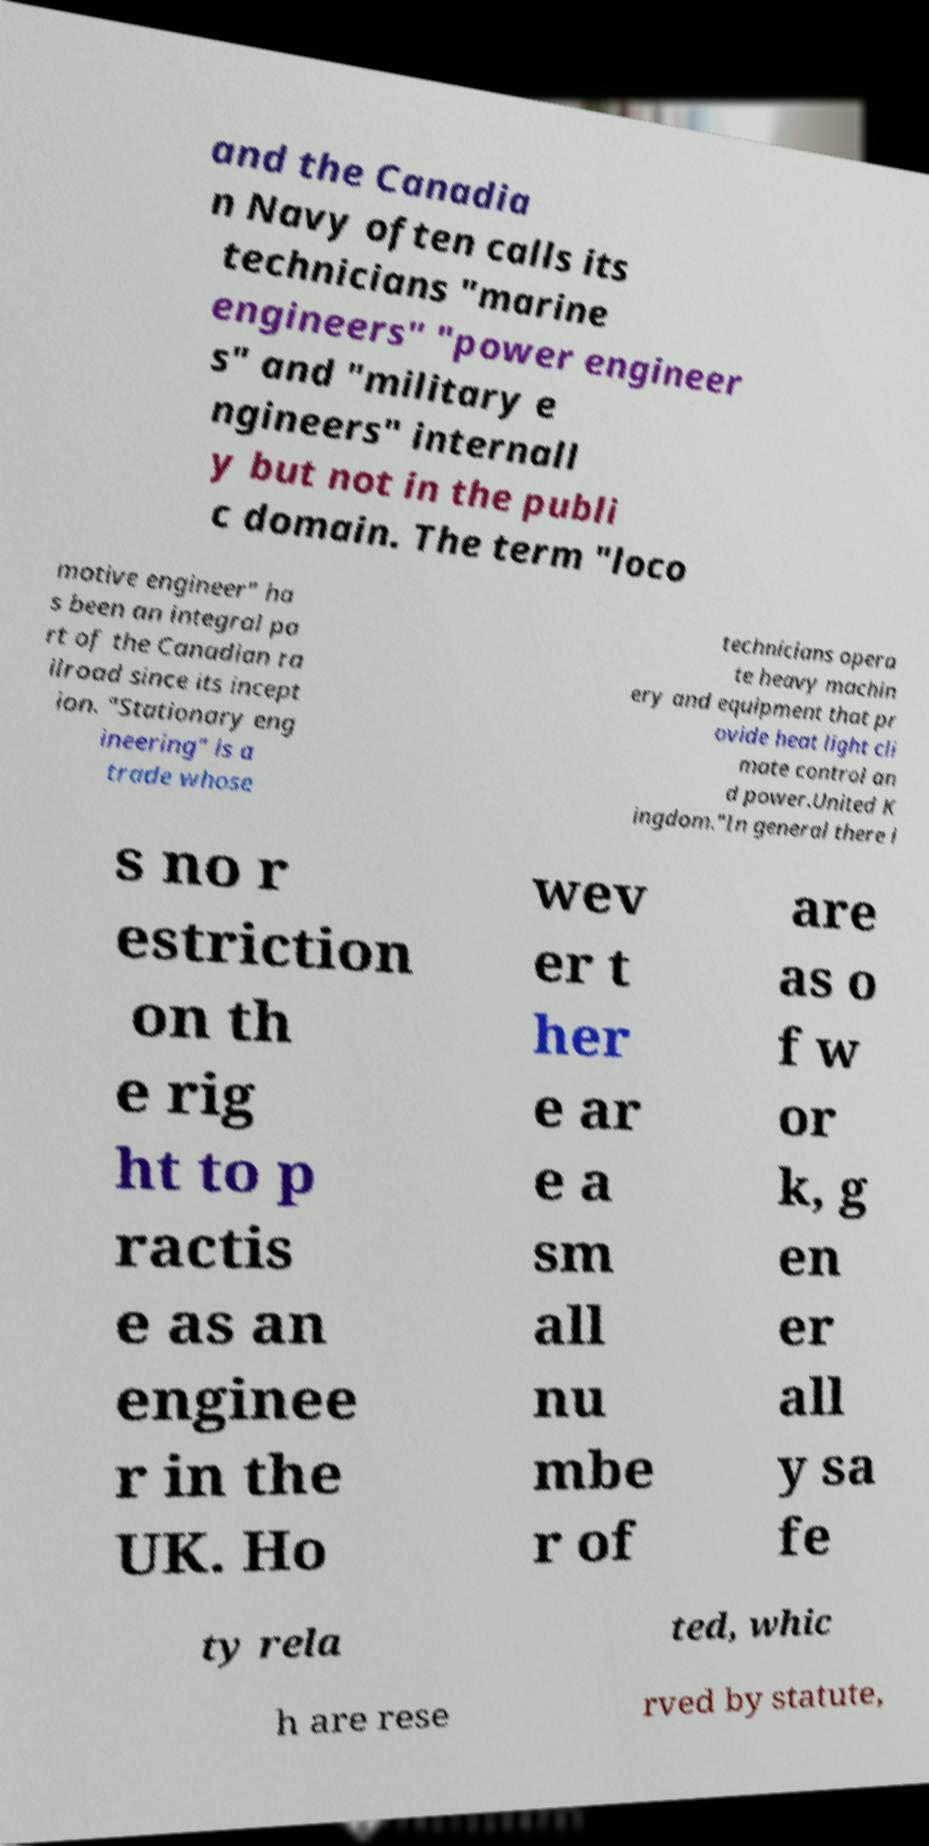For documentation purposes, I need the text within this image transcribed. Could you provide that? and the Canadia n Navy often calls its technicians "marine engineers" "power engineer s" and "military e ngineers" internall y but not in the publi c domain. The term "loco motive engineer" ha s been an integral pa rt of the Canadian ra ilroad since its incept ion. "Stationary eng ineering" is a trade whose technicians opera te heavy machin ery and equipment that pr ovide heat light cli mate control an d power.United K ingdom."In general there i s no r estriction on th e rig ht to p ractis e as an enginee r in the UK. Ho wev er t her e ar e a sm all nu mbe r of are as o f w or k, g en er all y sa fe ty rela ted, whic h are rese rved by statute, 